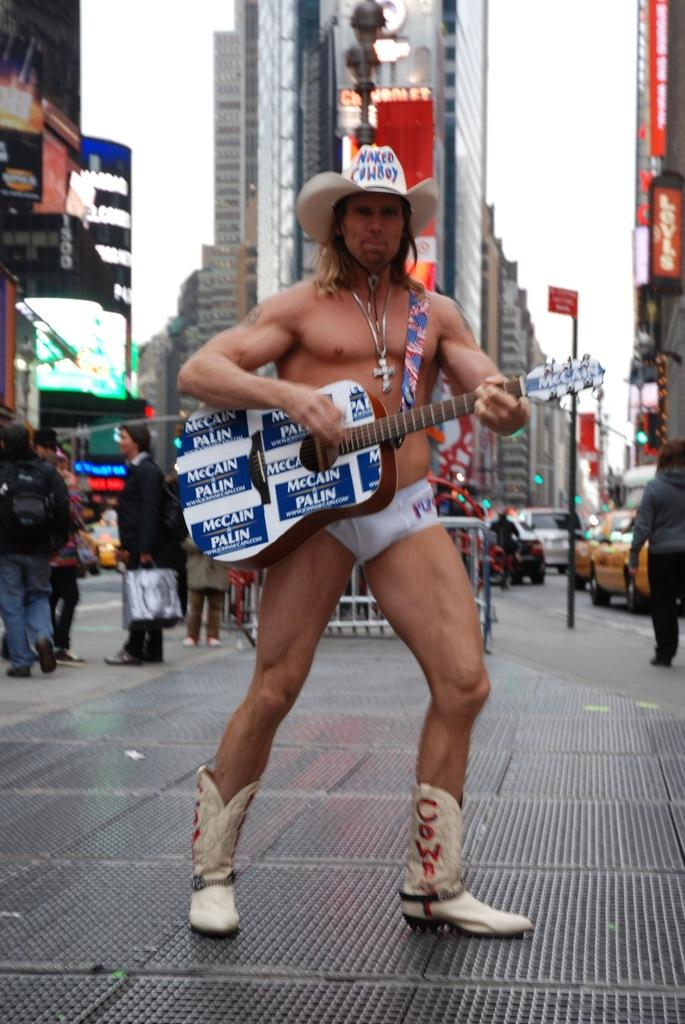What is the main subject of the image? There is a person in the image. What is the person wearing on their head? The person is wearing a hat. What is the person wearing around their neck? The person is wearing a chain. What is the person wearing on their feet? The person is wearing boots. What is the person doing in the image? The person is playing a guitar. What can be seen in the background of the image? There are buildings, persons standing with covers, poles, vehicles, flags, and banners in the background of the image. What type of quill is the person using to play the guitar in the image? There is no quill present in the image, and the person is playing a guitar with their hands, not a quill. How many eyes does the monkey have in the image? There is no monkey present in the image. 